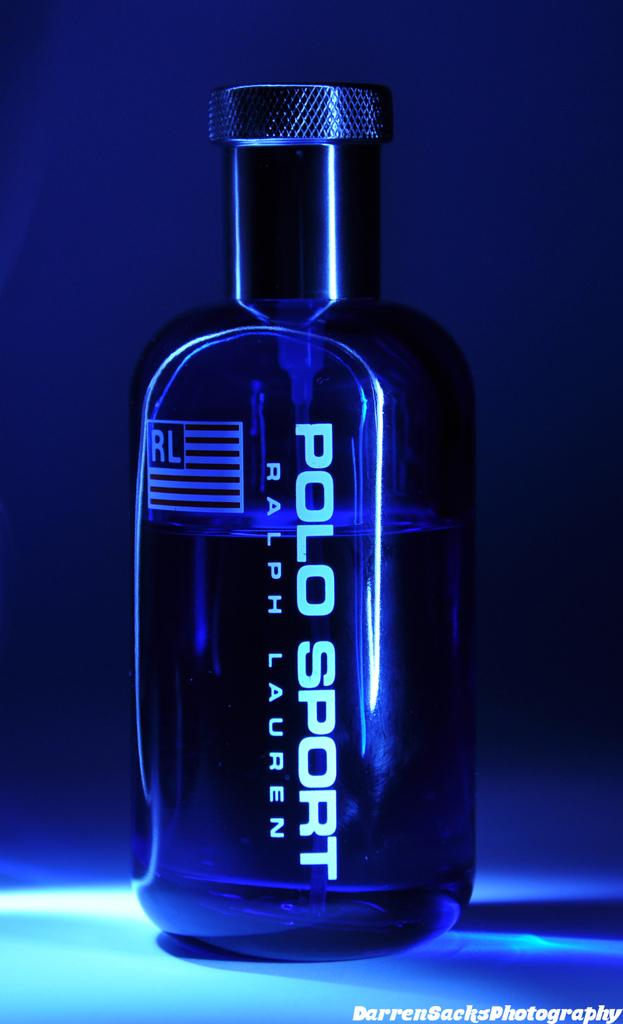<image>
Present a compact description of the photo's key features. A bottle of perfume called Polo Sport with an american flag logo on the left. 